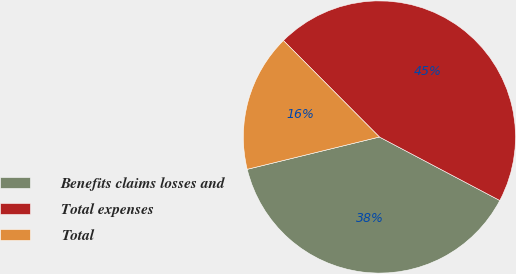Convert chart to OTSL. <chart><loc_0><loc_0><loc_500><loc_500><pie_chart><fcel>Benefits claims losses and<fcel>Total expenses<fcel>Total<nl><fcel>38.46%<fcel>45.19%<fcel>16.35%<nl></chart> 